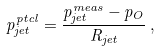Convert formula to latex. <formula><loc_0><loc_0><loc_500><loc_500>p _ { j e t } ^ { p t c l } = \frac { p _ { j e t } ^ { m e a s } - p _ { O } } { R _ { j e t } } \, ,</formula> 